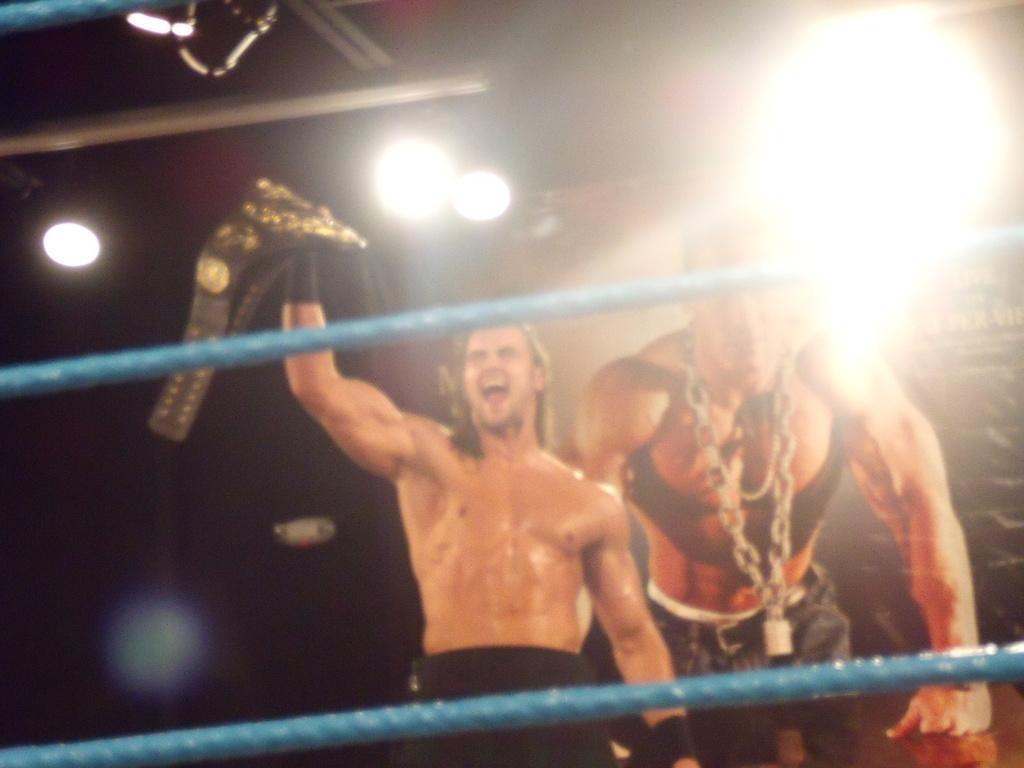Describe this image in one or two sentences. In this image there is a person standing in the wrestling ring and holding a belt in his hand. In the background there is a poster of a person. At the top of the image there is a ceiling with lights. 